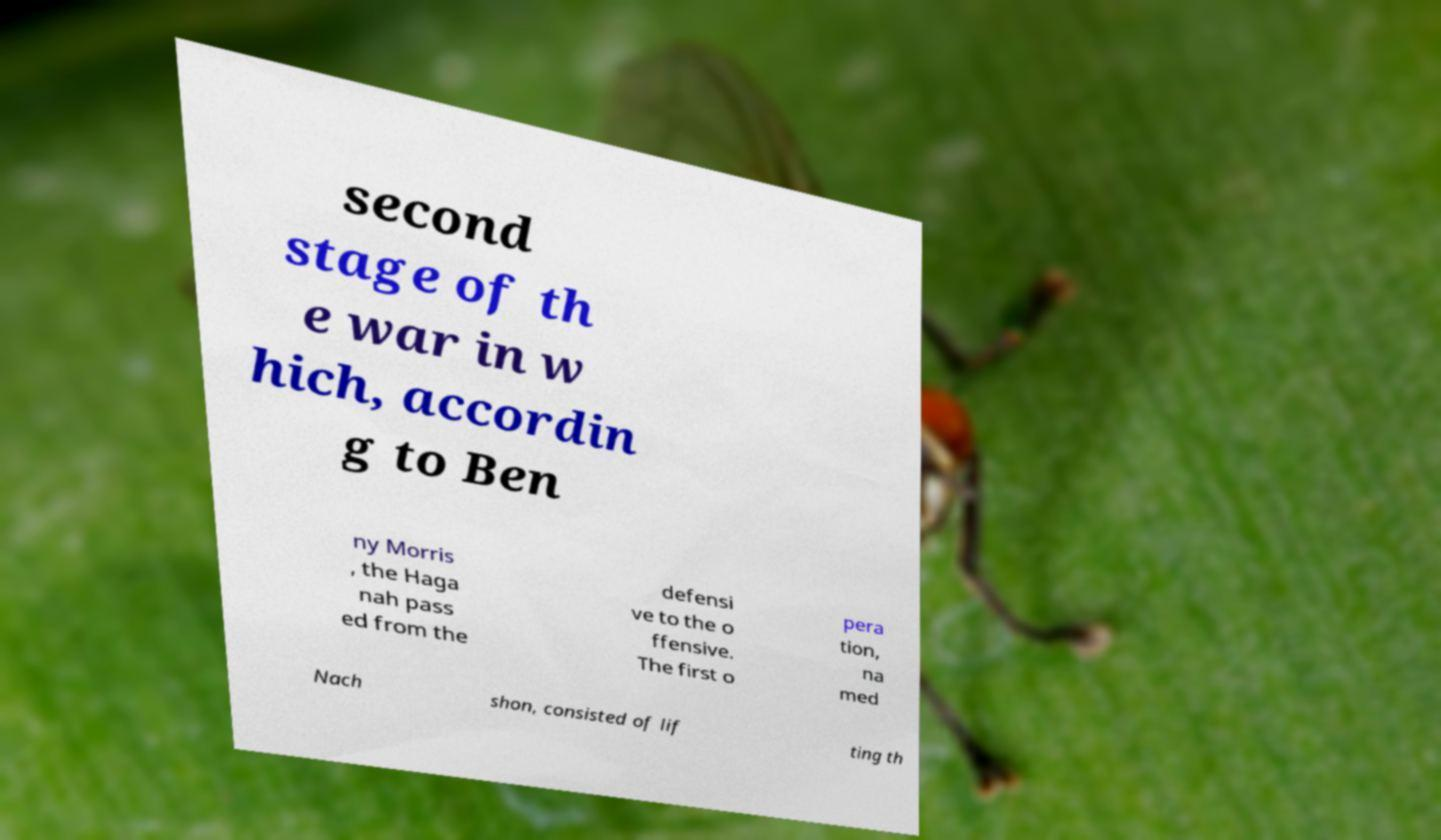Could you assist in decoding the text presented in this image and type it out clearly? second stage of th e war in w hich, accordin g to Ben ny Morris , the Haga nah pass ed from the defensi ve to the o ffensive. The first o pera tion, na med Nach shon, consisted of lif ting th 